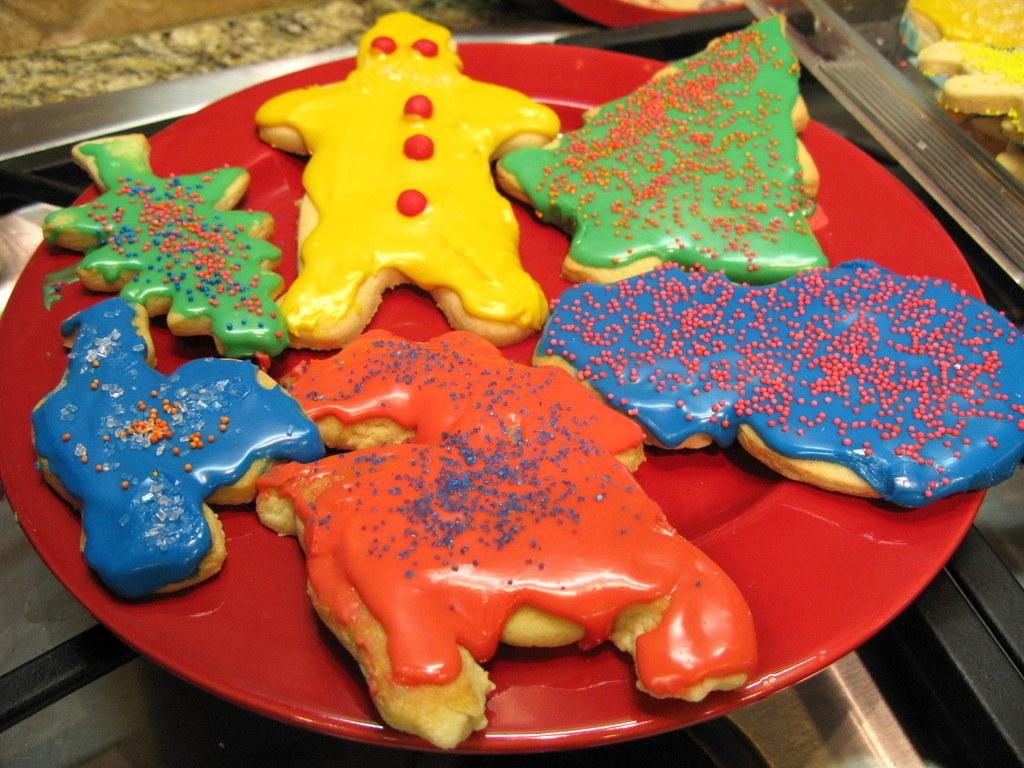What object is present on the table in the image? There is a plate in the image. What is on the plate? The plate contains food. Where is the plate located? The plate is placed on a table. Can you see a snail crawling up the hill in the image? There is no hill or snail present in the image. 